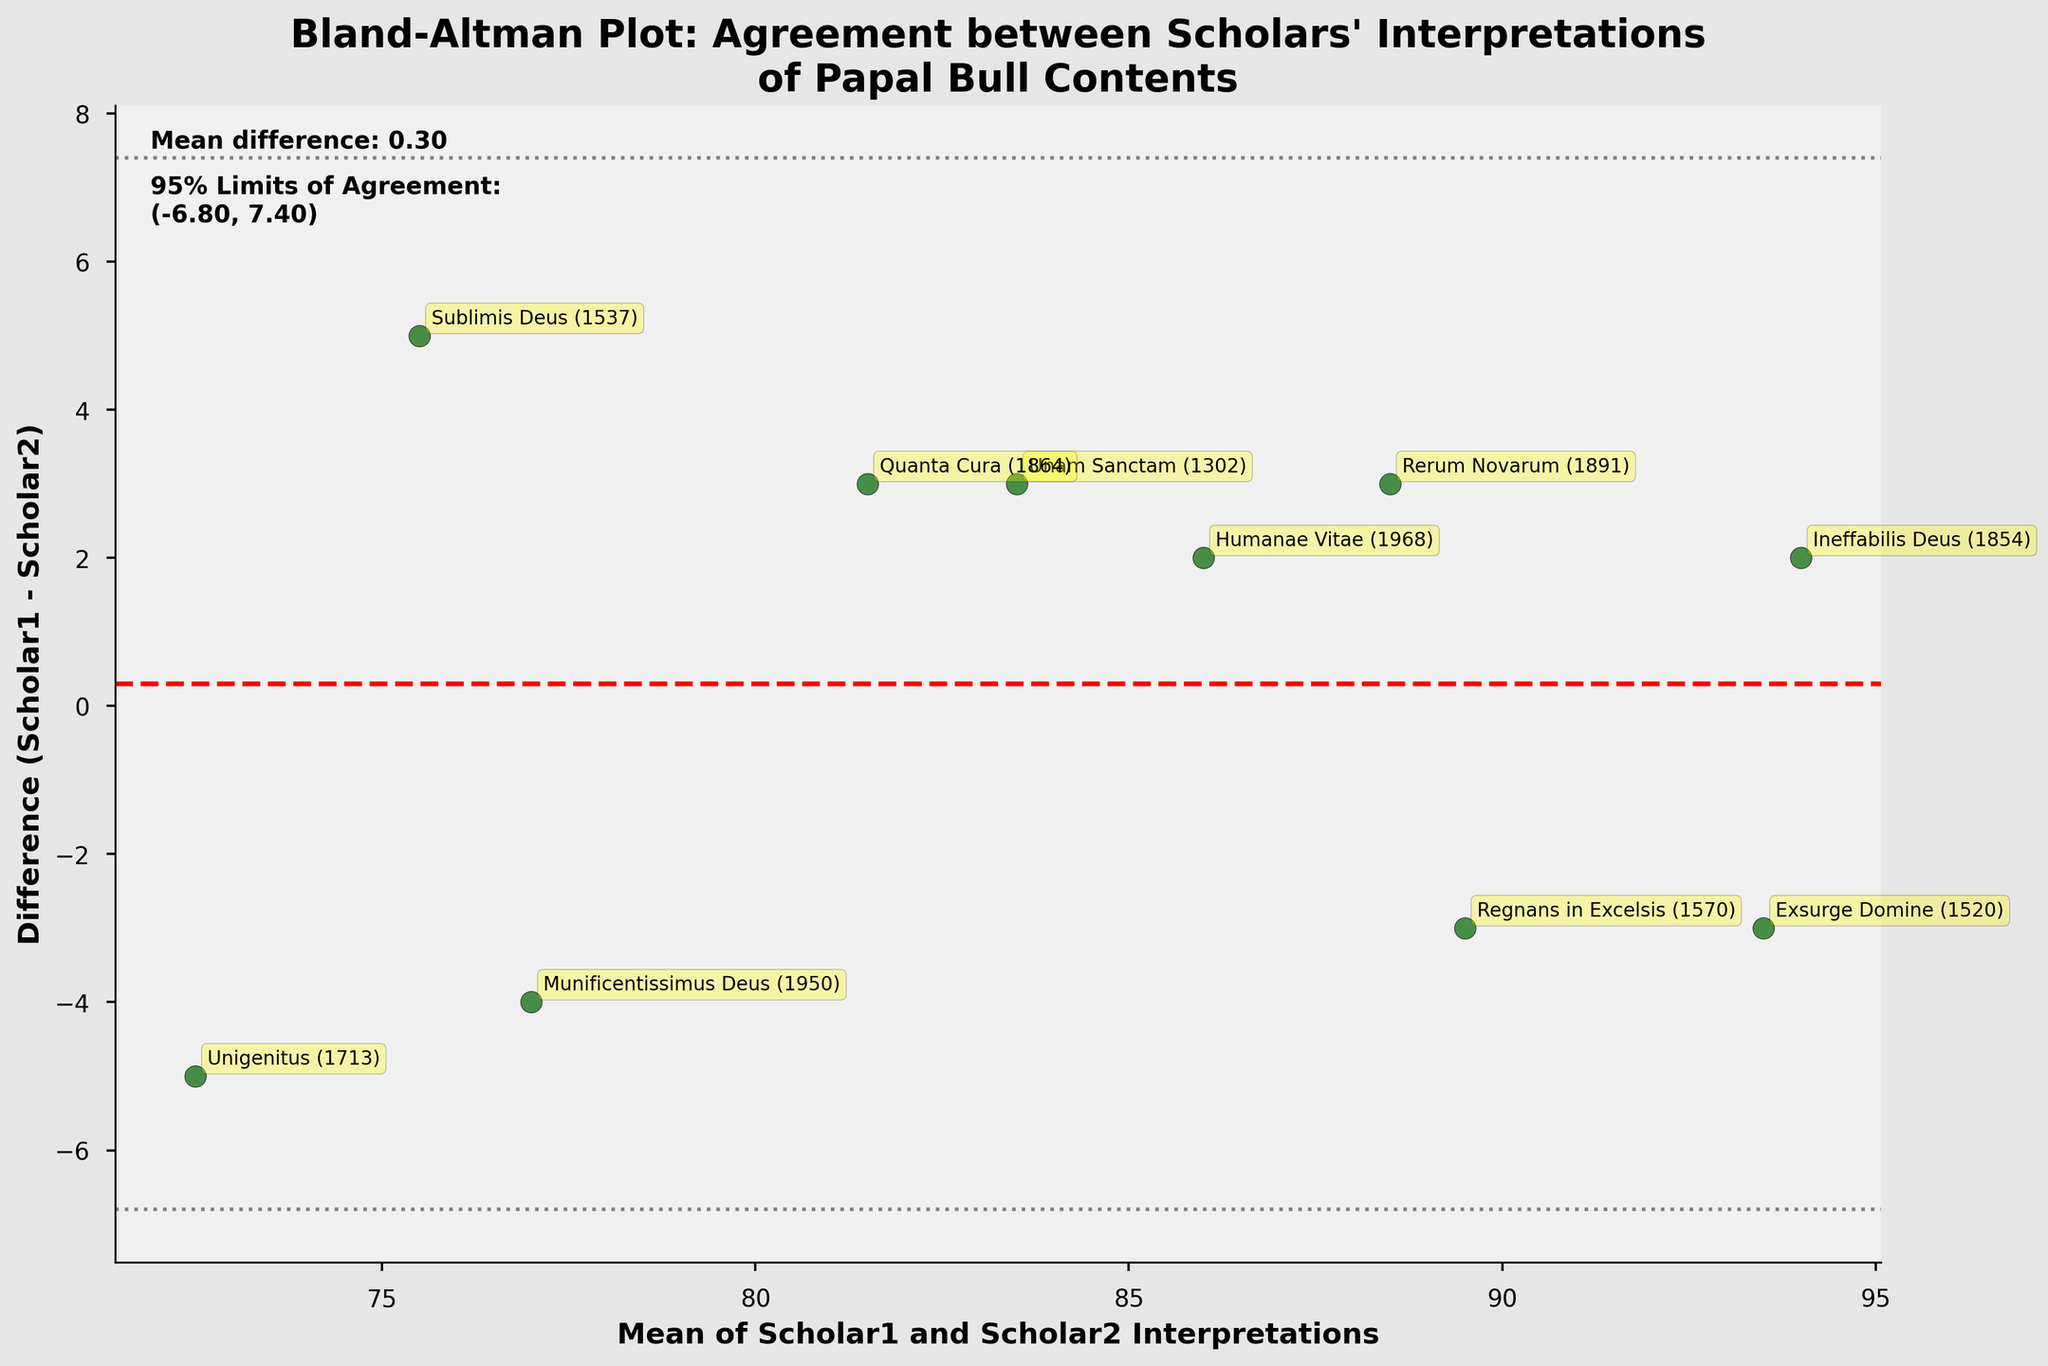What is the title of the plot? The title of the plot is written at the top of the figure in bold. It reads "Bland-Altman Plot: Agreement between Scholars' Interpretations of Papal Bull Contents".
Answer: Bland-Altman Plot: Agreement between Scholars' Interpretations of Papal Bull Contents How many data points are there in the plot? Each data point represents a pair of scholar interpretations for a papal bull. By counting the distinct data points in the scatter plot, we can determine there are 10 data points.
Answer: 10 What is the mean difference between Scholar1 and Scholar2 interpretations? The mean difference is shown near the top-left of the plot under "Mean difference:". This value represents the average of differences between Scholar1 and Scholar2 interpretations across all papal bulls analyzed. It is labeled as "Mean difference: 0.20".
Answer: 0.20 What is the range of the 95% limits of agreement? The 95% limits of agreement are indicated by two horizontal dashed lines on the plot, and their exact values are provided near the plot in text form as "95% Limits of Agreement: (-5.92, 6.32)". These values represent the interval within which 95% of the differences between Scholar1 and Scholar2 interpretations are expected to lie.
Answer: (-5.92, 6.32) Which papal bull has the largest positive difference between Scholar1 and Scholar2 interpretations? By looking at the scatter points and their associated annotations, we see that "Unigenitus (1713)" is the highest point on the positive side of the difference axis.
Answer: Unigenitus (1713) Which papal bull is associated with the smallest average interpretation (mean value)? The average interpretation is given by the mean of Scholar1's and Scholar2's interpretations. The horizontal axis shows this mean value. The smallest mean value appears for the data point corresponding to "Unigenitus (1713)" which is around 72.5.
Answer: Unigenitus (1713) Which papal bull lies closest to the 0 difference line? The scatter point nearest to the horizontal line at difference 0 represents the papal bull where Scholar1's and Scholar2's interpretations are most aligned. This point is associated with "Humanae Vitae (1968)".
Answer: Humanae Vitae (1968) Compare the interpretations of "Exsurge Domine (1520)" and "Quanta Cura (1864)". Which has a higher mean interpretation? The points are placed on the horizontal axis based on the mean of Scholar1's and Scholar2's interpretations. The point for "Exsurge Domine (1520)" has a higher mean value compared to "Quanta Cura (1864)", which is evident by its position further right on the horizontal axis.
Answer: Exsurge Domine (1520) Is there any papal bull where Scholar1's interpretation is precisely 5 units greater than Scholar2's? The difference axis shows the difference between Scholar1 and Scholar2's interpretations. One point stands exactly at the difference of 5, which is associated with "Sublimis Deus (1537)".
Answer: Sublimis Deus (1537) 